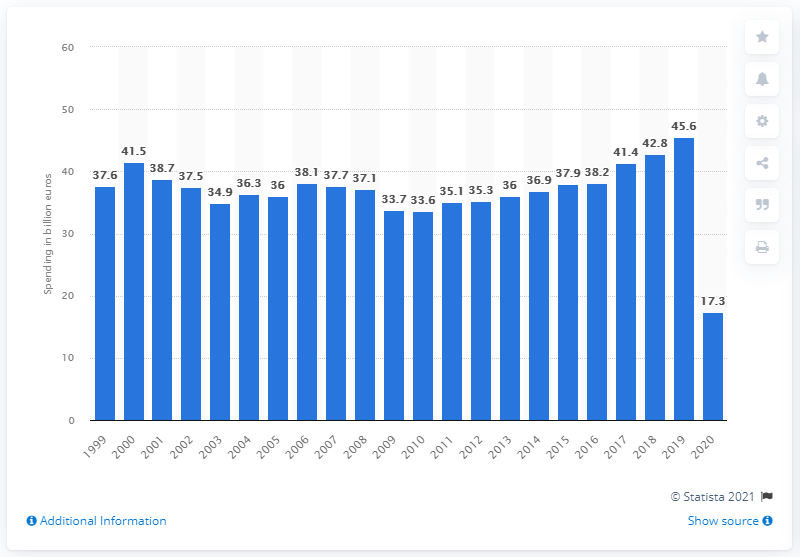Specify some key components in this picture. In 2020, the total amount of money spent by visitors to Italy on tourism-related expenses was 17.3 billion U.S. dollars. 